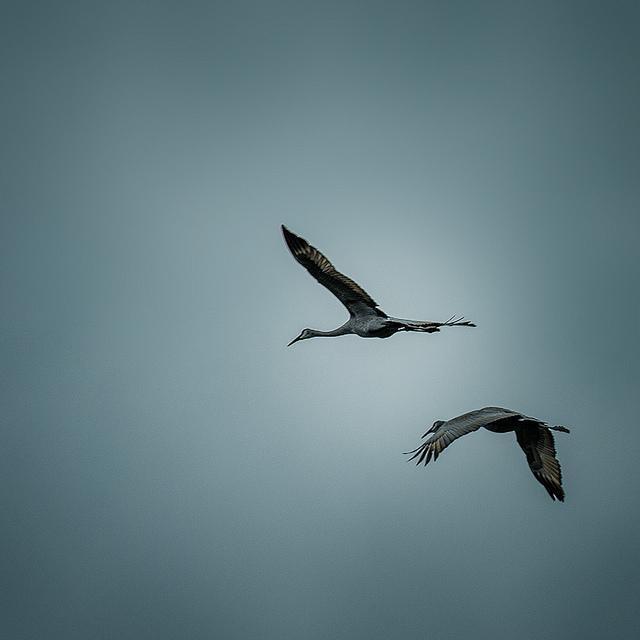How many birds?
Give a very brief answer. 2. How many birds are in the air?
Give a very brief answer. 2. How many birds are flying?
Give a very brief answer. 2. How many birds are there?
Give a very brief answer. 2. 